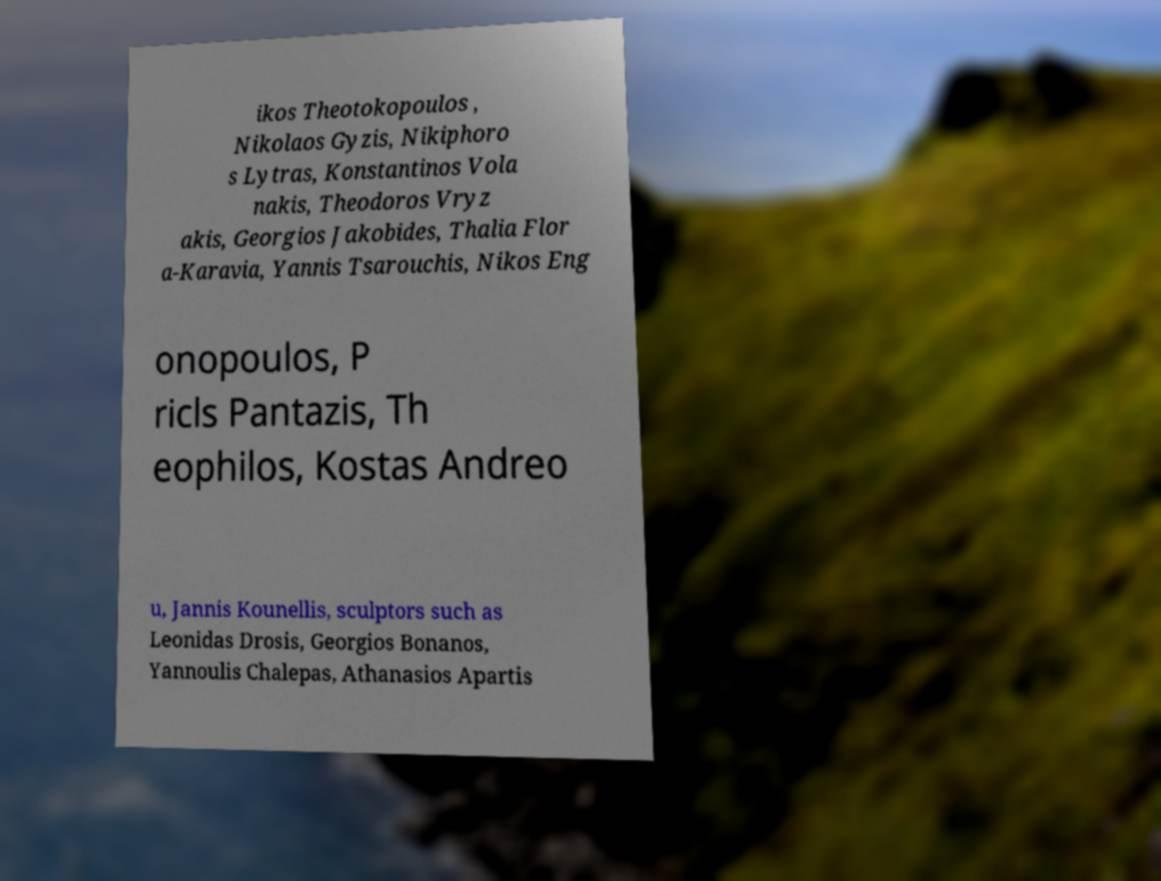Could you extract and type out the text from this image? ikos Theotokopoulos , Nikolaos Gyzis, Nikiphoro s Lytras, Konstantinos Vola nakis, Theodoros Vryz akis, Georgios Jakobides, Thalia Flor a-Karavia, Yannis Tsarouchis, Nikos Eng onopoulos, P ricls Pantazis, Th eophilos, Kostas Andreo u, Jannis Kounellis, sculptors such as Leonidas Drosis, Georgios Bonanos, Yannoulis Chalepas, Athanasios Apartis 